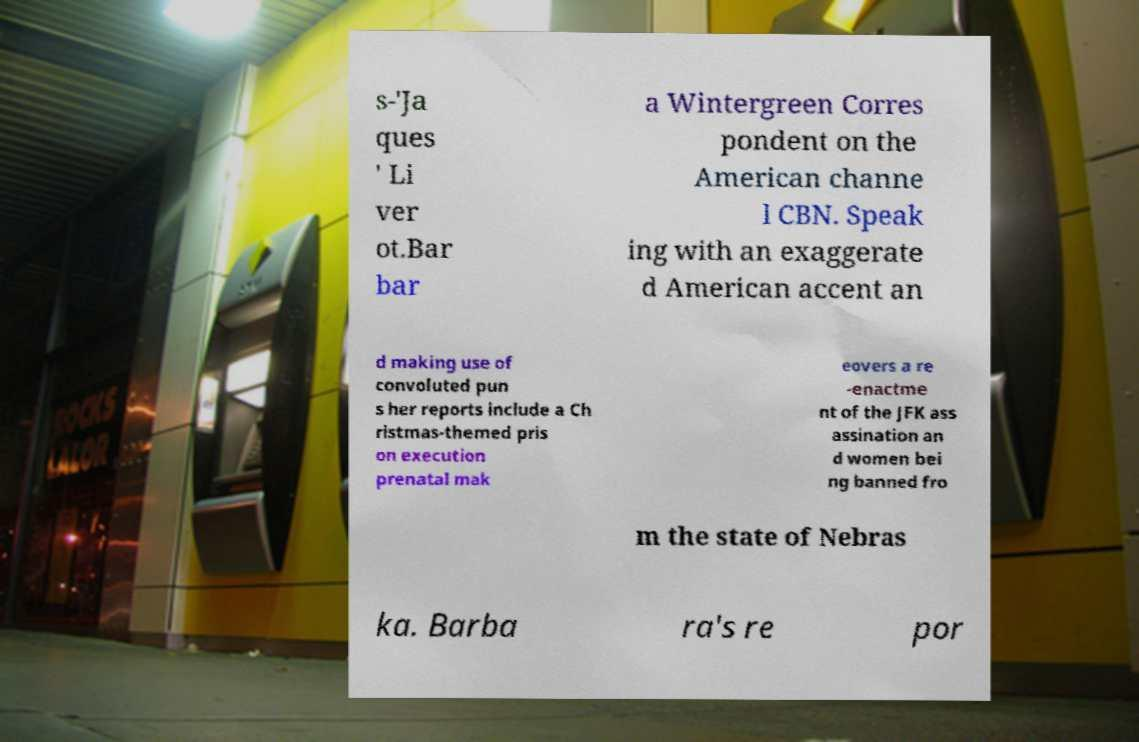What messages or text are displayed in this image? I need them in a readable, typed format. s-'Ja ques ' Li ver ot.Bar bar a Wintergreen Corres pondent on the American channe l CBN. Speak ing with an exaggerate d American accent an d making use of convoluted pun s her reports include a Ch ristmas-themed pris on execution prenatal mak eovers a re -enactme nt of the JFK ass assination an d women bei ng banned fro m the state of Nebras ka. Barba ra's re por 